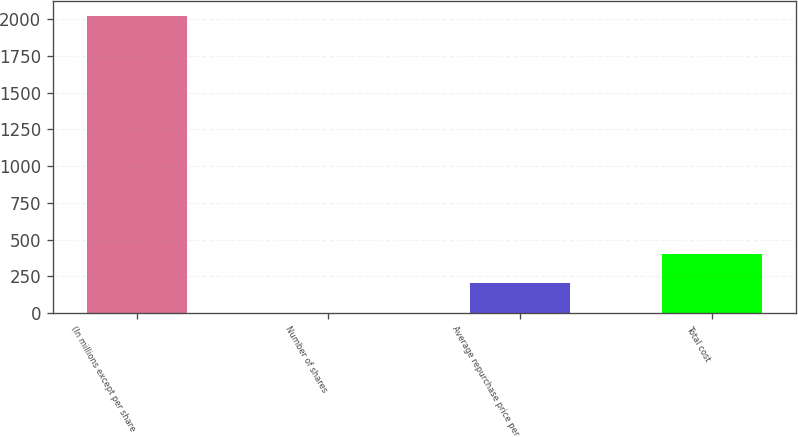Convert chart. <chart><loc_0><loc_0><loc_500><loc_500><bar_chart><fcel>(In millions except per share<fcel>Number of shares<fcel>Average repurchase price per<fcel>Total cost<nl><fcel>2019<fcel>1.4<fcel>203.16<fcel>404.92<nl></chart> 